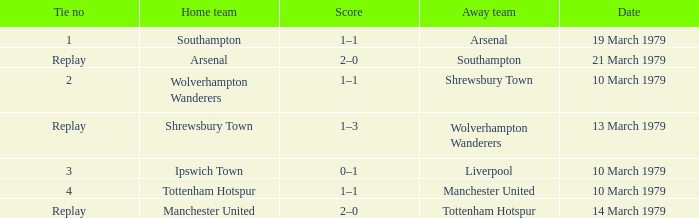What was the score of the tie that had Tottenham Hotspur as the home team? 1–1. 